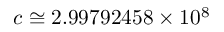<formula> <loc_0><loc_0><loc_500><loc_500>c \cong 2 . 9 9 7 9 2 4 5 8 \times 1 0 ^ { 8 }</formula> 